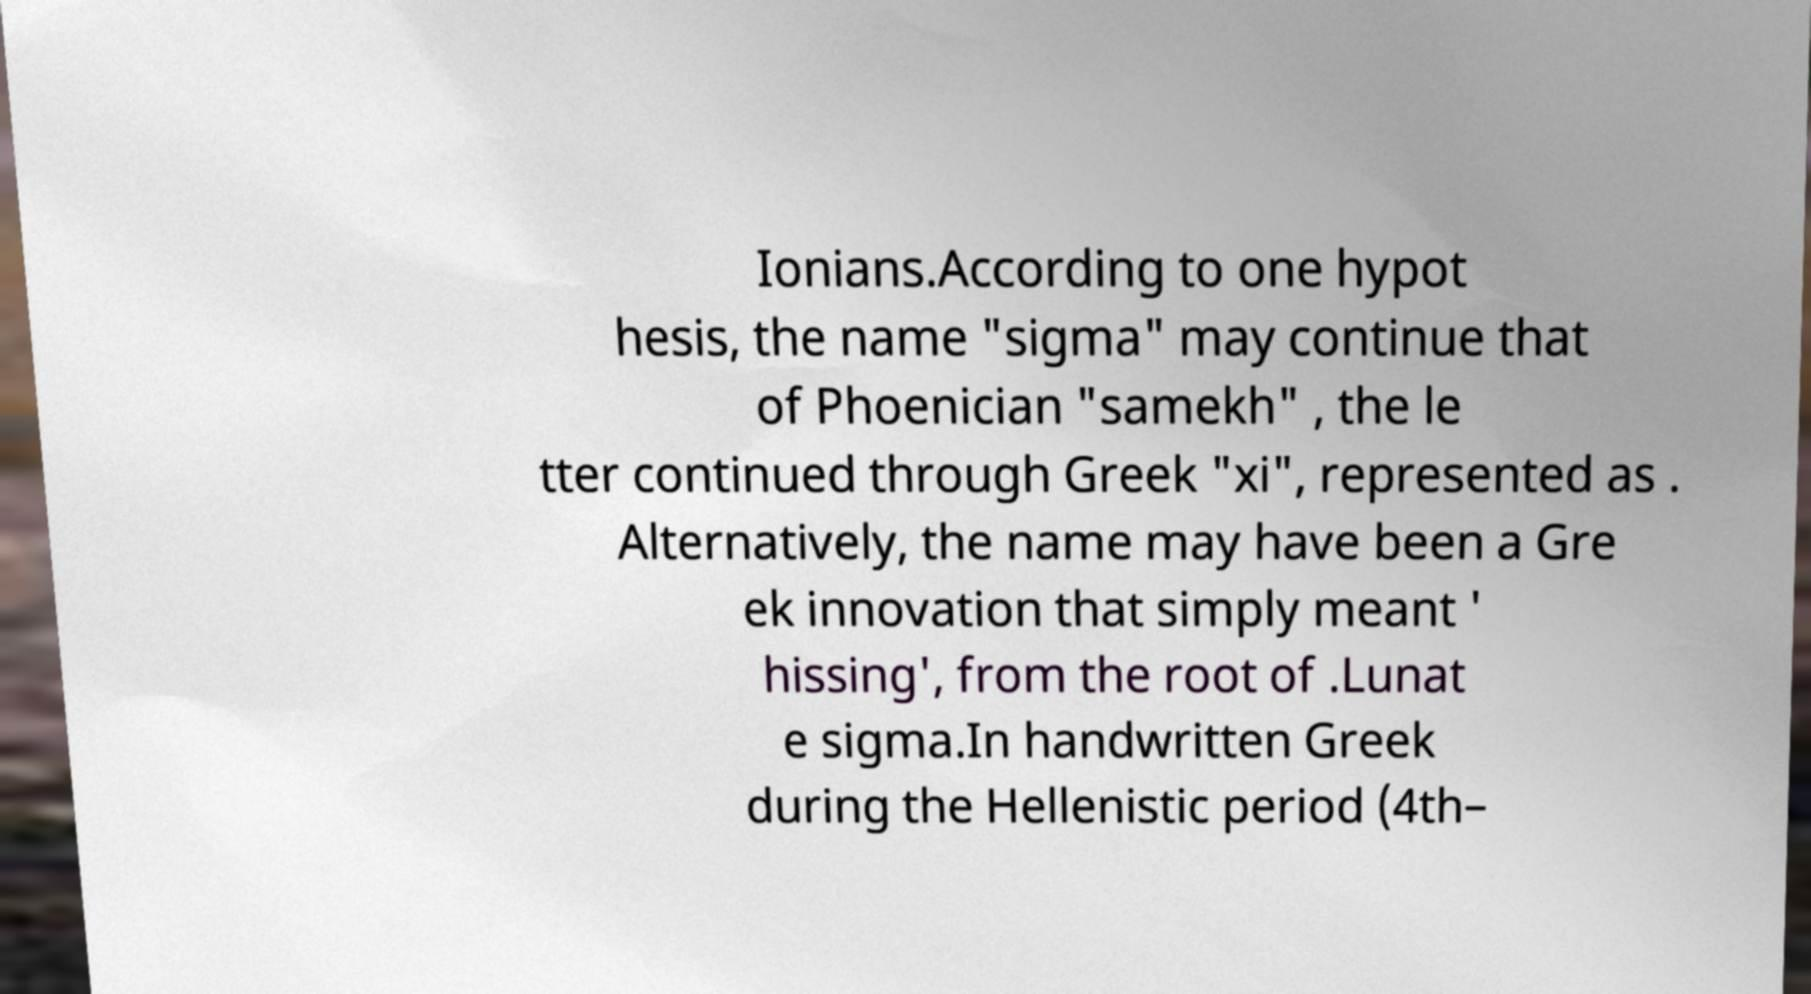Please identify and transcribe the text found in this image. Ionians.According to one hypot hesis, the name "sigma" may continue that of Phoenician "samekh" , the le tter continued through Greek "xi", represented as . Alternatively, the name may have been a Gre ek innovation that simply meant ' hissing', from the root of .Lunat e sigma.In handwritten Greek during the Hellenistic period (4th– 